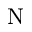Convert formula to latex. <formula><loc_0><loc_0><loc_500><loc_500>N</formula> 